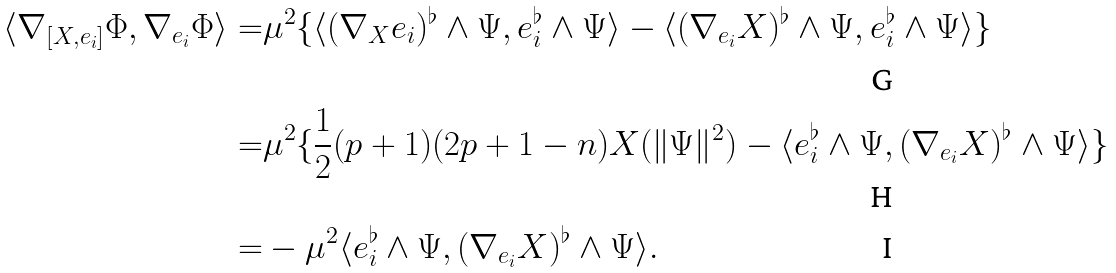Convert formula to latex. <formula><loc_0><loc_0><loc_500><loc_500>\langle \nabla _ { [ X , e _ { i } ] } \Phi , \nabla _ { e _ { i } } \Phi \rangle = & \mu ^ { 2 } \{ \langle ( \nabla _ { X } e _ { i } ) ^ { \flat } \wedge \Psi , e _ { i } ^ { \flat } \wedge \Psi \rangle - \langle ( \nabla _ { e _ { i } } X ) ^ { \flat } \wedge \Psi , e _ { i } ^ { \flat } \wedge \Psi \rangle \} \\ = & \mu ^ { 2 } \{ \frac { 1 } { 2 } ( p + 1 ) ( 2 p + 1 - n ) X ( \| \Psi \| ^ { 2 } ) - \langle e _ { i } ^ { \flat } \wedge \Psi , ( \nabla _ { e _ { i } } X ) ^ { \flat } \wedge \Psi \rangle \} \\ = & - \mu ^ { 2 } \langle e _ { i } ^ { \flat } \wedge \Psi , ( \nabla _ { e _ { i } } X ) ^ { \flat } \wedge \Psi \rangle .</formula> 